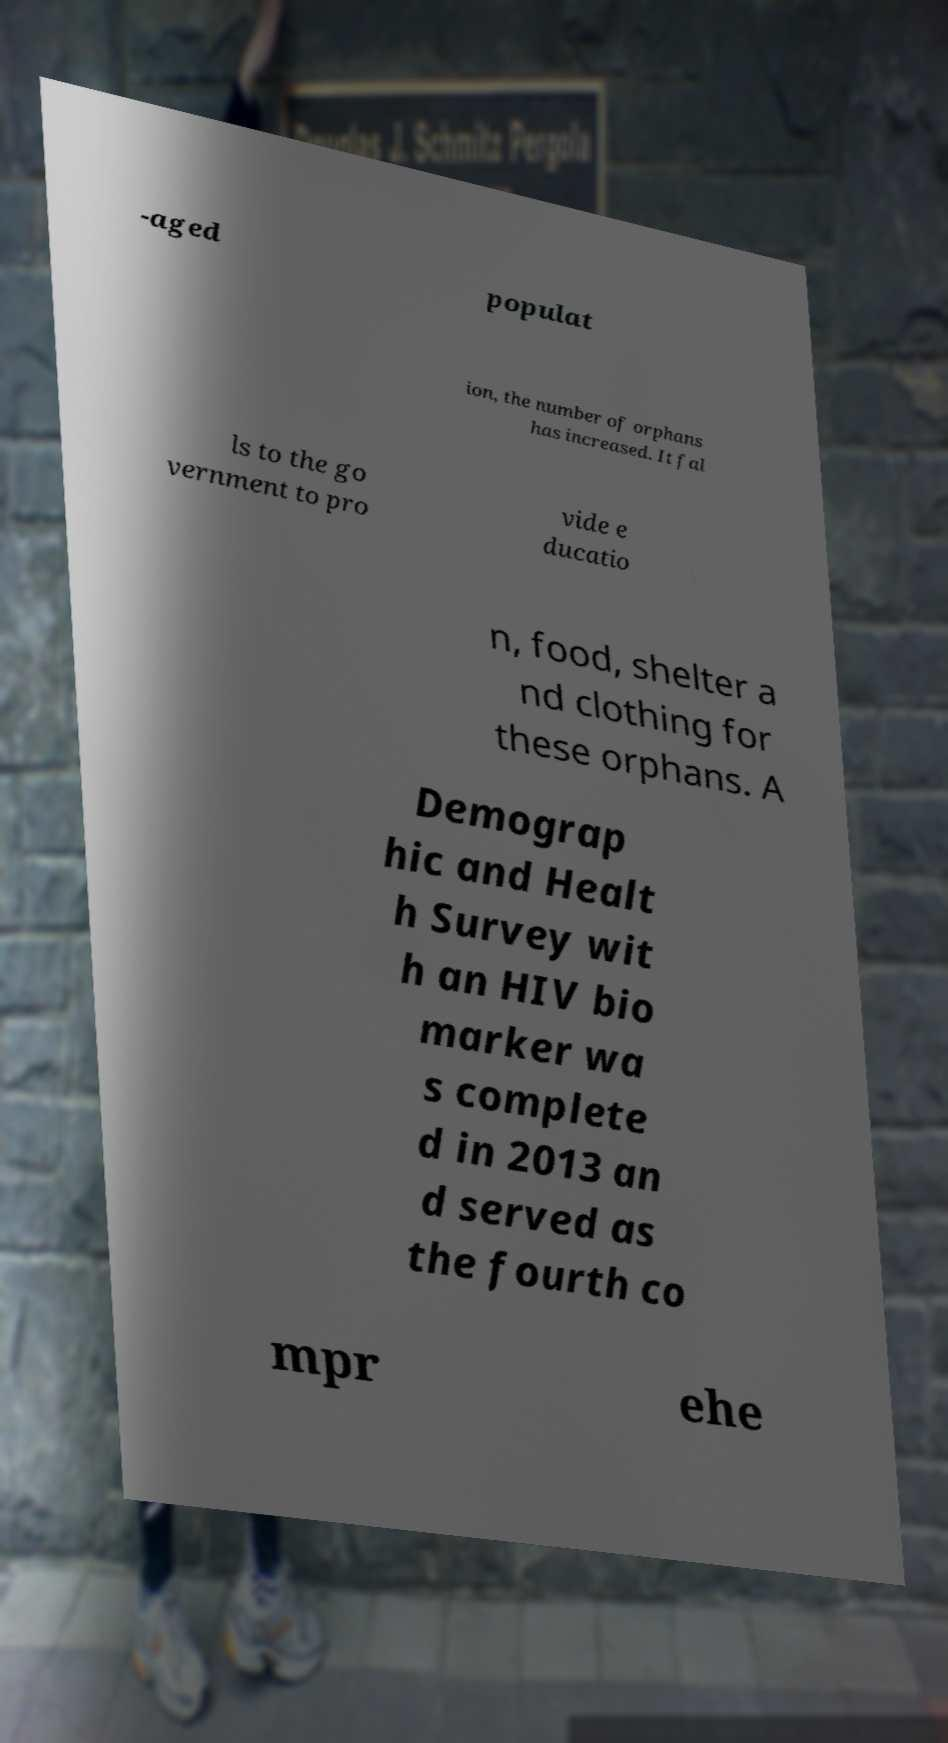Can you accurately transcribe the text from the provided image for me? -aged populat ion, the number of orphans has increased. It fal ls to the go vernment to pro vide e ducatio n, food, shelter a nd clothing for these orphans. A Demograp hic and Healt h Survey wit h an HIV bio marker wa s complete d in 2013 an d served as the fourth co mpr ehe 